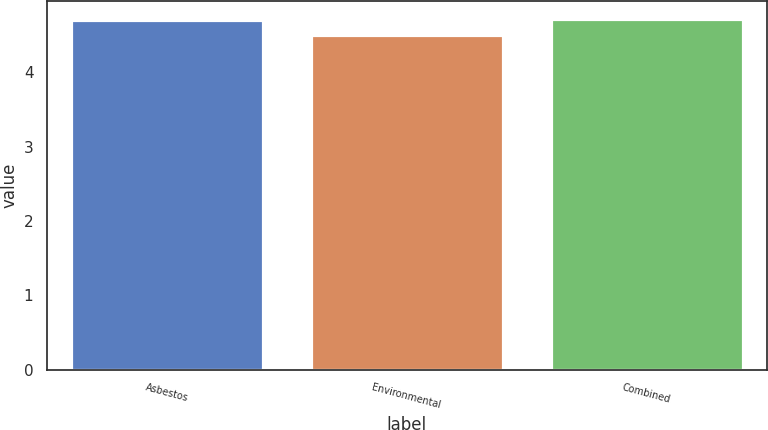<chart> <loc_0><loc_0><loc_500><loc_500><bar_chart><fcel>Asbestos<fcel>Environmental<fcel>Combined<nl><fcel>4.7<fcel>4.5<fcel>4.72<nl></chart> 